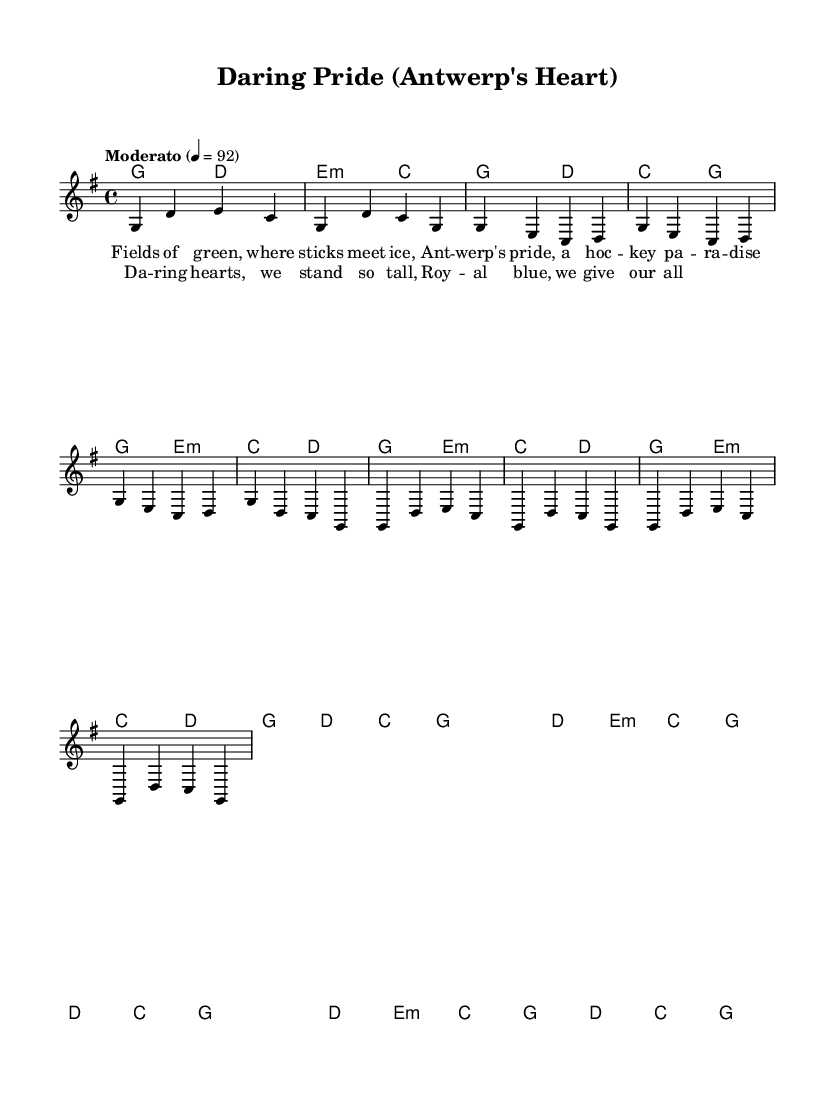What is the key signature of this music? The key signature is G major, indicated by one sharp (F#).
Answer: G major What is the time signature of this music? The time signature is 4/4, which means there are four beats in each measure.
Answer: 4/4 What is the tempo marking for this piece? The tempo marking is "Moderato," which indicates a moderate speed.
Answer: Moderato How many measures are in the chorus section? The chorus section has four measures, as indicated by the rhythmic notation.
Answer: Four What is the second chord in the intro? The second chord in the intro is D major, as printed in the chord symbols.
Answer: D major What are the last words of the chorus? The last words of the chorus are "we give our all," completing the lyrical thought.
Answer: we give our all What emotion does the song convey based on its lyrics? The song conveys pride and unity related to the local hockey culture.
Answer: Pride 